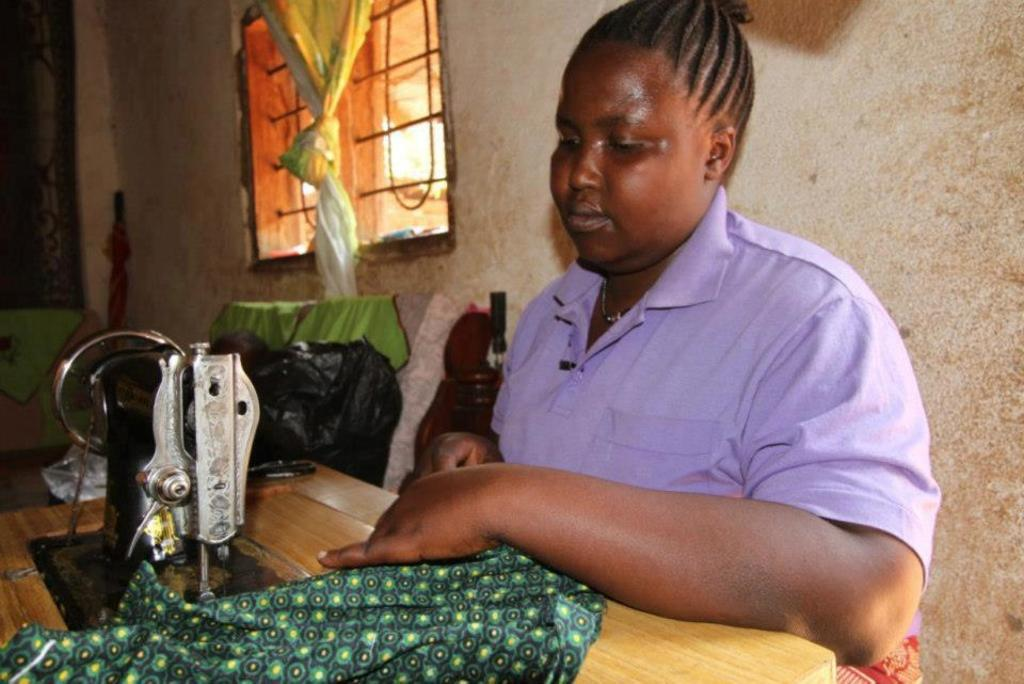What can be seen in the background of the image? There is a wall and a window in the background of the image. What is associated with the window in the image? There is a curtain associated with the window. Who is present in the image? There is a woman in the image. What is the woman doing in the image? The woman is in front of a sewing machine. What is the woman holding in her hand? The woman is holding a piece of cloth in her hand. What type of mint is the woman using to make a decision in the image? There is no mint or decision-making process depicted in the image; it shows a woman working with a sewing machine and holding a piece of cloth. 